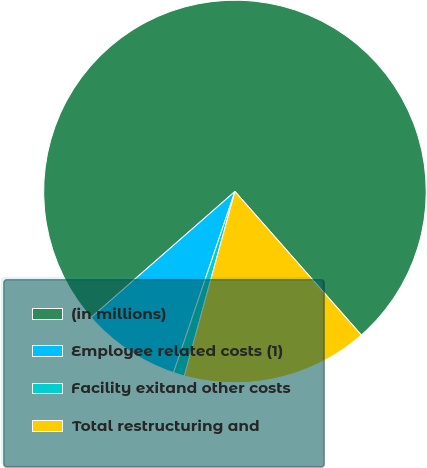Convert chart to OTSL. <chart><loc_0><loc_0><loc_500><loc_500><pie_chart><fcel>(in millions)<fcel>Employee related costs (1)<fcel>Facility exitand other costs<fcel>Total restructuring and<nl><fcel>74.96%<fcel>8.35%<fcel>0.94%<fcel>15.75%<nl></chart> 